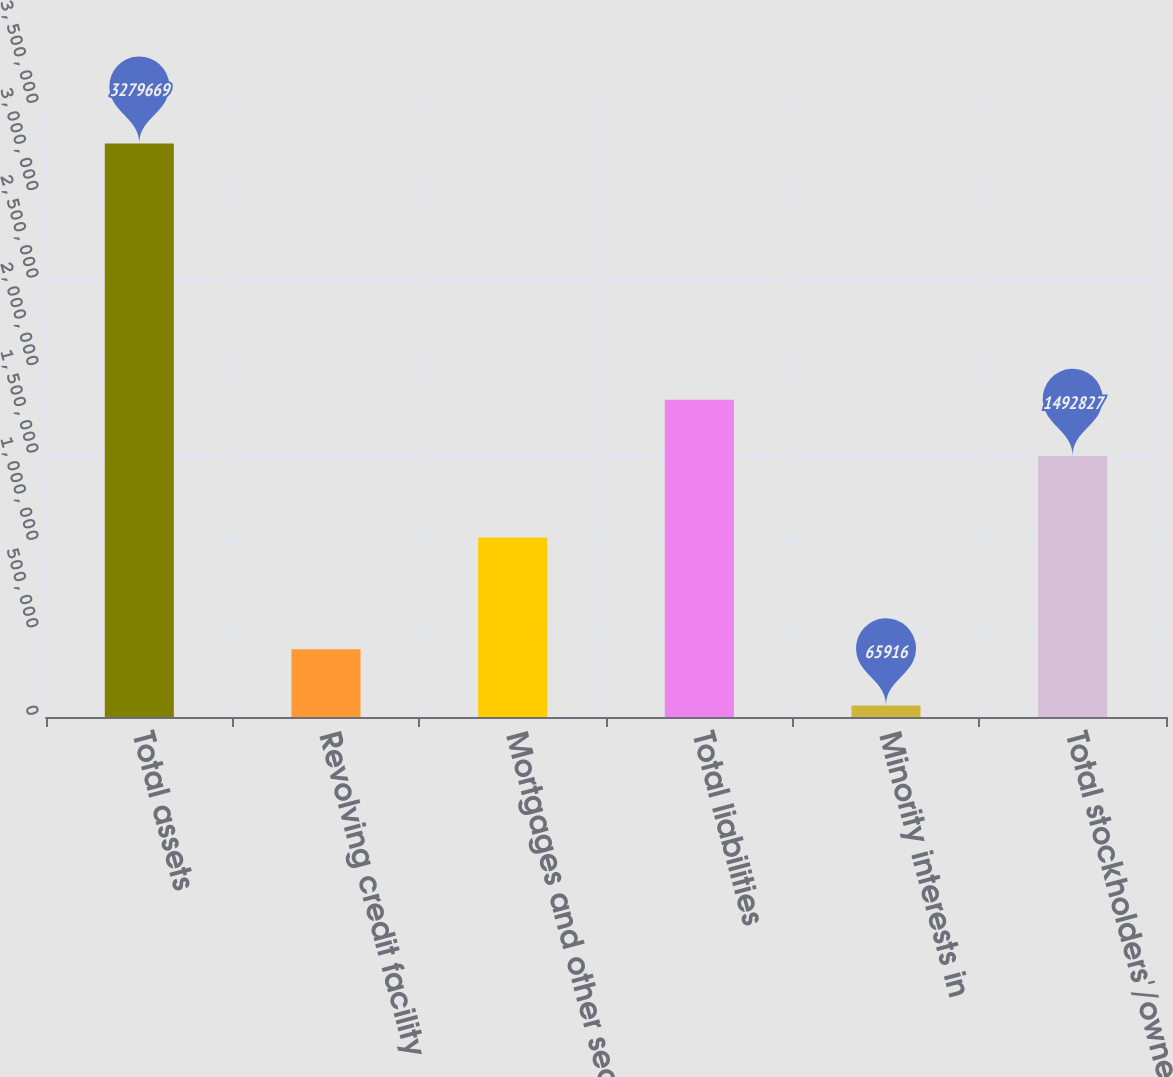Convert chart. <chart><loc_0><loc_0><loc_500><loc_500><bar_chart><fcel>Total assets<fcel>Revolving credit facility<fcel>Mortgages and other secured<fcel>Total liabilities<fcel>Minority interests in<fcel>Total stockholders'/owner's<nl><fcel>3.27967e+06<fcel>387291<fcel>1.02659e+06<fcel>1.8142e+06<fcel>65916<fcel>1.49283e+06<nl></chart> 